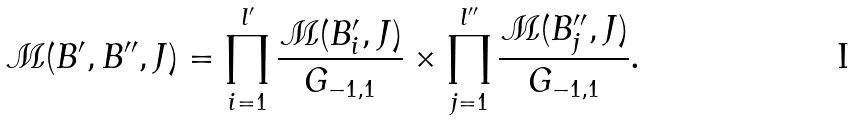Convert formula to latex. <formula><loc_0><loc_0><loc_500><loc_500>\mathcal { M } ( B ^ { \prime } , B ^ { \prime \prime } , J ) = \prod _ { i = 1 } ^ { l ^ { \prime } } \frac { \mathcal { M } ( B ^ { \prime } _ { i } , J ) } { G _ { - 1 , 1 } } \times \prod _ { j = 1 } ^ { l ^ { \prime \prime } } \frac { \mathcal { M } ( B ^ { \prime \prime } _ { j } , J ) } { G _ { - 1 , 1 } } .</formula> 